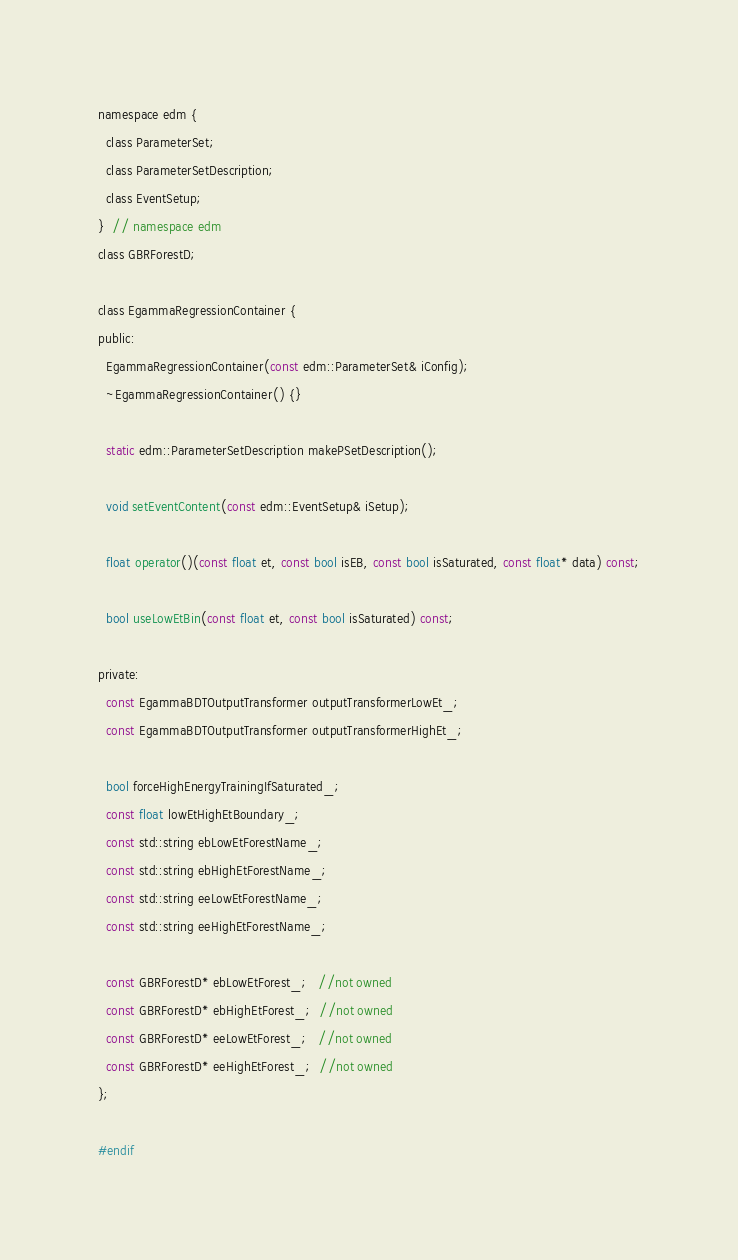<code> <loc_0><loc_0><loc_500><loc_500><_C_>namespace edm {
  class ParameterSet;
  class ParameterSetDescription;
  class EventSetup;
}  // namespace edm
class GBRForestD;

class EgammaRegressionContainer {
public:
  EgammaRegressionContainer(const edm::ParameterSet& iConfig);
  ~EgammaRegressionContainer() {}

  static edm::ParameterSetDescription makePSetDescription();

  void setEventContent(const edm::EventSetup& iSetup);

  float operator()(const float et, const bool isEB, const bool isSaturated, const float* data) const;

  bool useLowEtBin(const float et, const bool isSaturated) const;

private:
  const EgammaBDTOutputTransformer outputTransformerLowEt_;
  const EgammaBDTOutputTransformer outputTransformerHighEt_;

  bool forceHighEnergyTrainingIfSaturated_;
  const float lowEtHighEtBoundary_;
  const std::string ebLowEtForestName_;
  const std::string ebHighEtForestName_;
  const std::string eeLowEtForestName_;
  const std::string eeHighEtForestName_;

  const GBRForestD* ebLowEtForest_;   //not owned
  const GBRForestD* ebHighEtForest_;  //not owned
  const GBRForestD* eeLowEtForest_;   //not owned
  const GBRForestD* eeHighEtForest_;  //not owned
};

#endif
</code> 